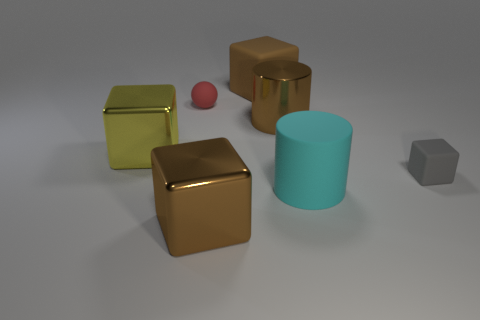Subtract all purple cylinders. How many brown cubes are left? 2 Subtract all large cubes. How many cubes are left? 1 Add 3 yellow blocks. How many objects exist? 10 Subtract all gray cubes. How many cubes are left? 3 Subtract all blocks. Subtract all tiny gray matte things. How many objects are left? 2 Add 6 big metal cylinders. How many big metal cylinders are left? 7 Add 1 yellow metallic blocks. How many yellow metallic blocks exist? 2 Subtract 0 purple spheres. How many objects are left? 7 Subtract all spheres. How many objects are left? 6 Subtract all gray cylinders. Subtract all red cubes. How many cylinders are left? 2 